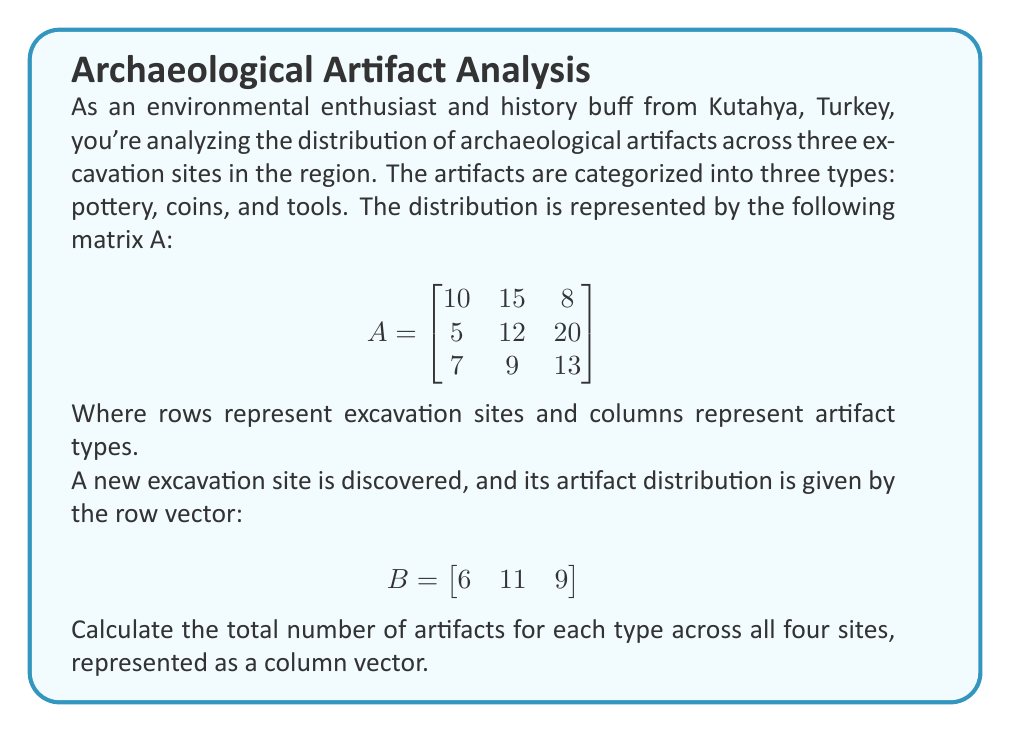Show me your answer to this math problem. To solve this problem, we need to follow these steps:

1. Understand the given matrices:
   - Matrix A represents the distribution of artifacts in the first three sites.
   - Vector B represents the distribution in the newly discovered site.

2. To get the total number of artifacts for each type across all four sites, we need to:
   - Sum up the columns of matrix A
   - Add the corresponding elements from vector B

3. Let's sum up the columns of matrix A:
   $$\begin{aligned}
   \text{Pottery:} & 10 + 5 + 7 = 22 \\
   \text{Coins:} & 15 + 12 + 9 = 36 \\
   \text{Tools:} & 8 + 20 + 13 = 41
   \end{aligned}$$

4. Now, let's add the corresponding elements from vector B:
   $$\begin{aligned}
   \text{Pottery:} & 22 + 6 = 28 \\
   \text{Coins:} & 36 + 11 = 47 \\
   \text{Tools:} & 41 + 9 = 50
   \end{aligned}$$

5. We can represent this result as a column vector:
   $$\begin{bmatrix}
   28 \\
   47 \\
   50
   \end{bmatrix}$$

This column vector represents the total number of artifacts for each type (pottery, coins, and tools, respectively) across all four excavation sites.
Answer: $$\begin{bmatrix}
28 \\
47 \\
50
\end{bmatrix}$$ 